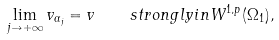<formula> <loc_0><loc_0><loc_500><loc_500>\lim _ { j \to + \infty } v _ { \alpha _ { j } } = v \quad s t r o n g l y i n W ^ { 1 , p } ( \Omega _ { 1 } ) ,</formula> 